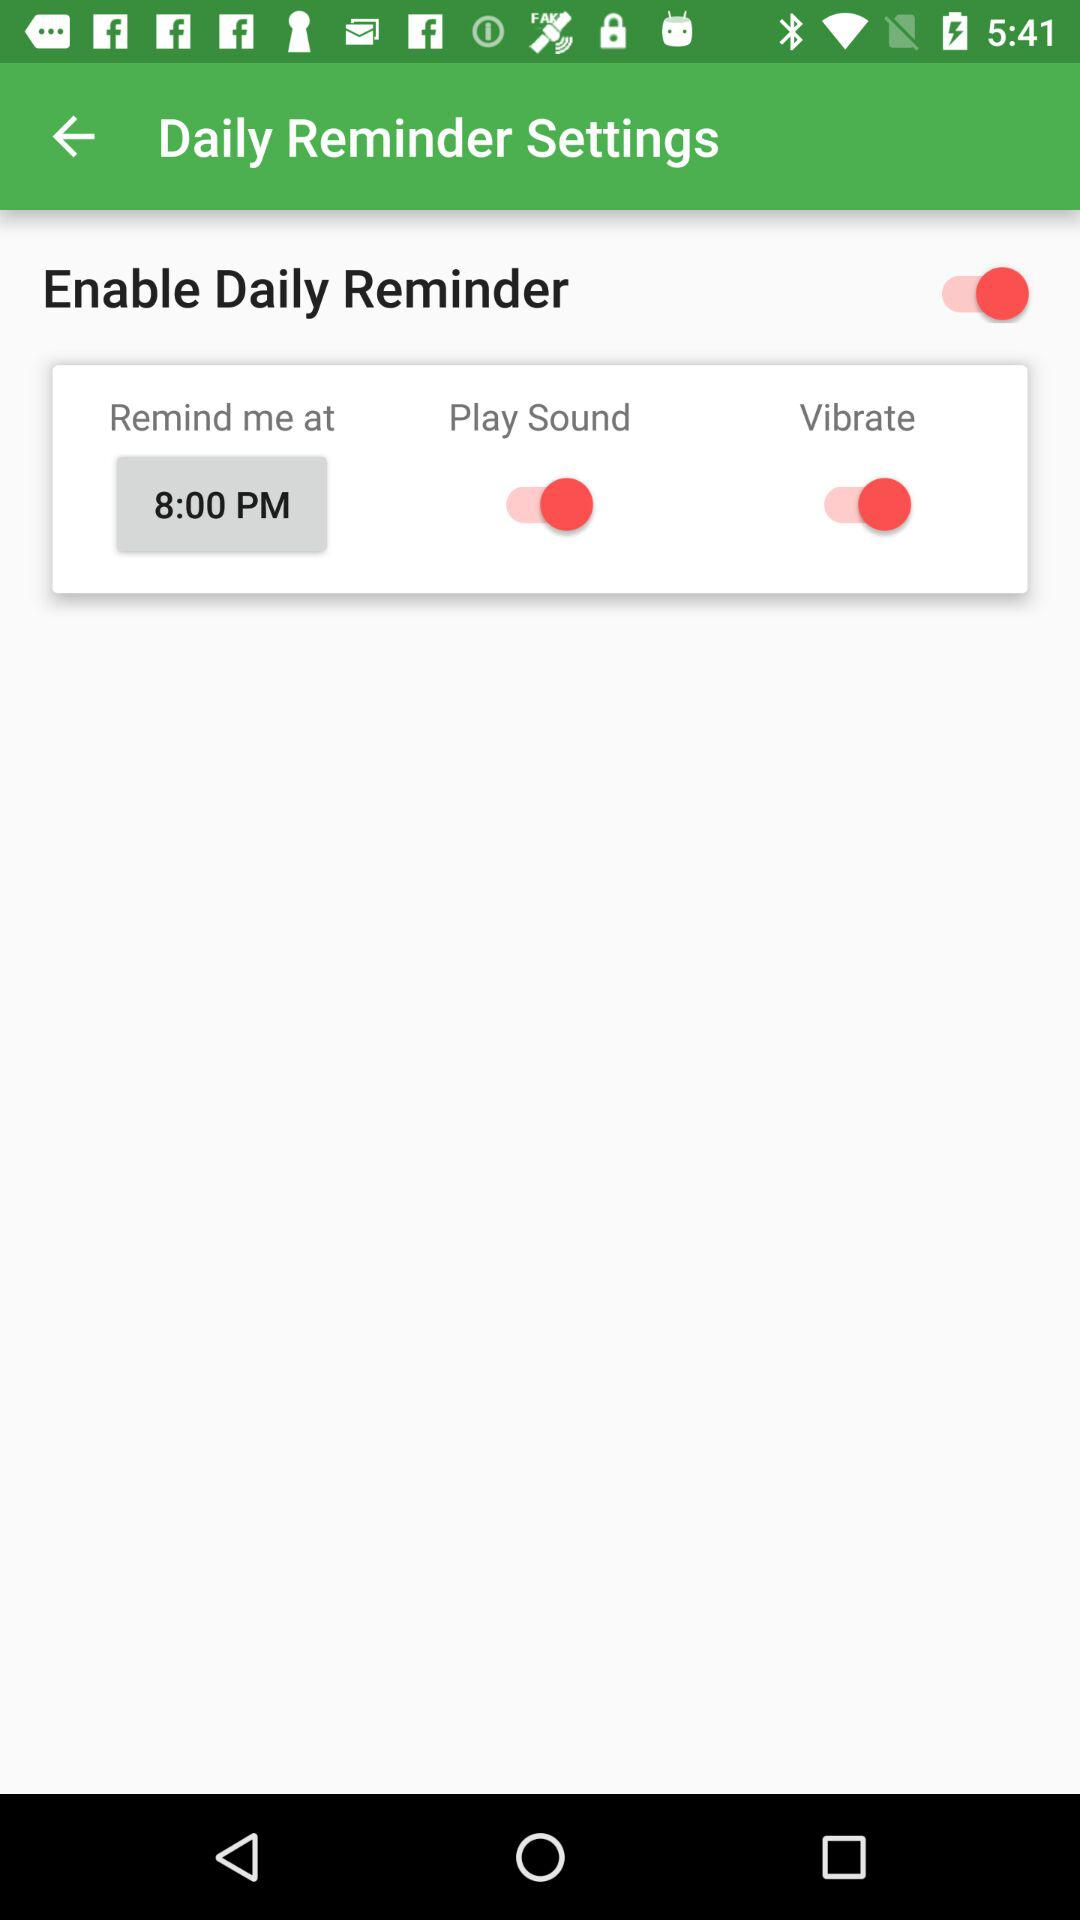What is the status of the Play Sound? The status is on. 